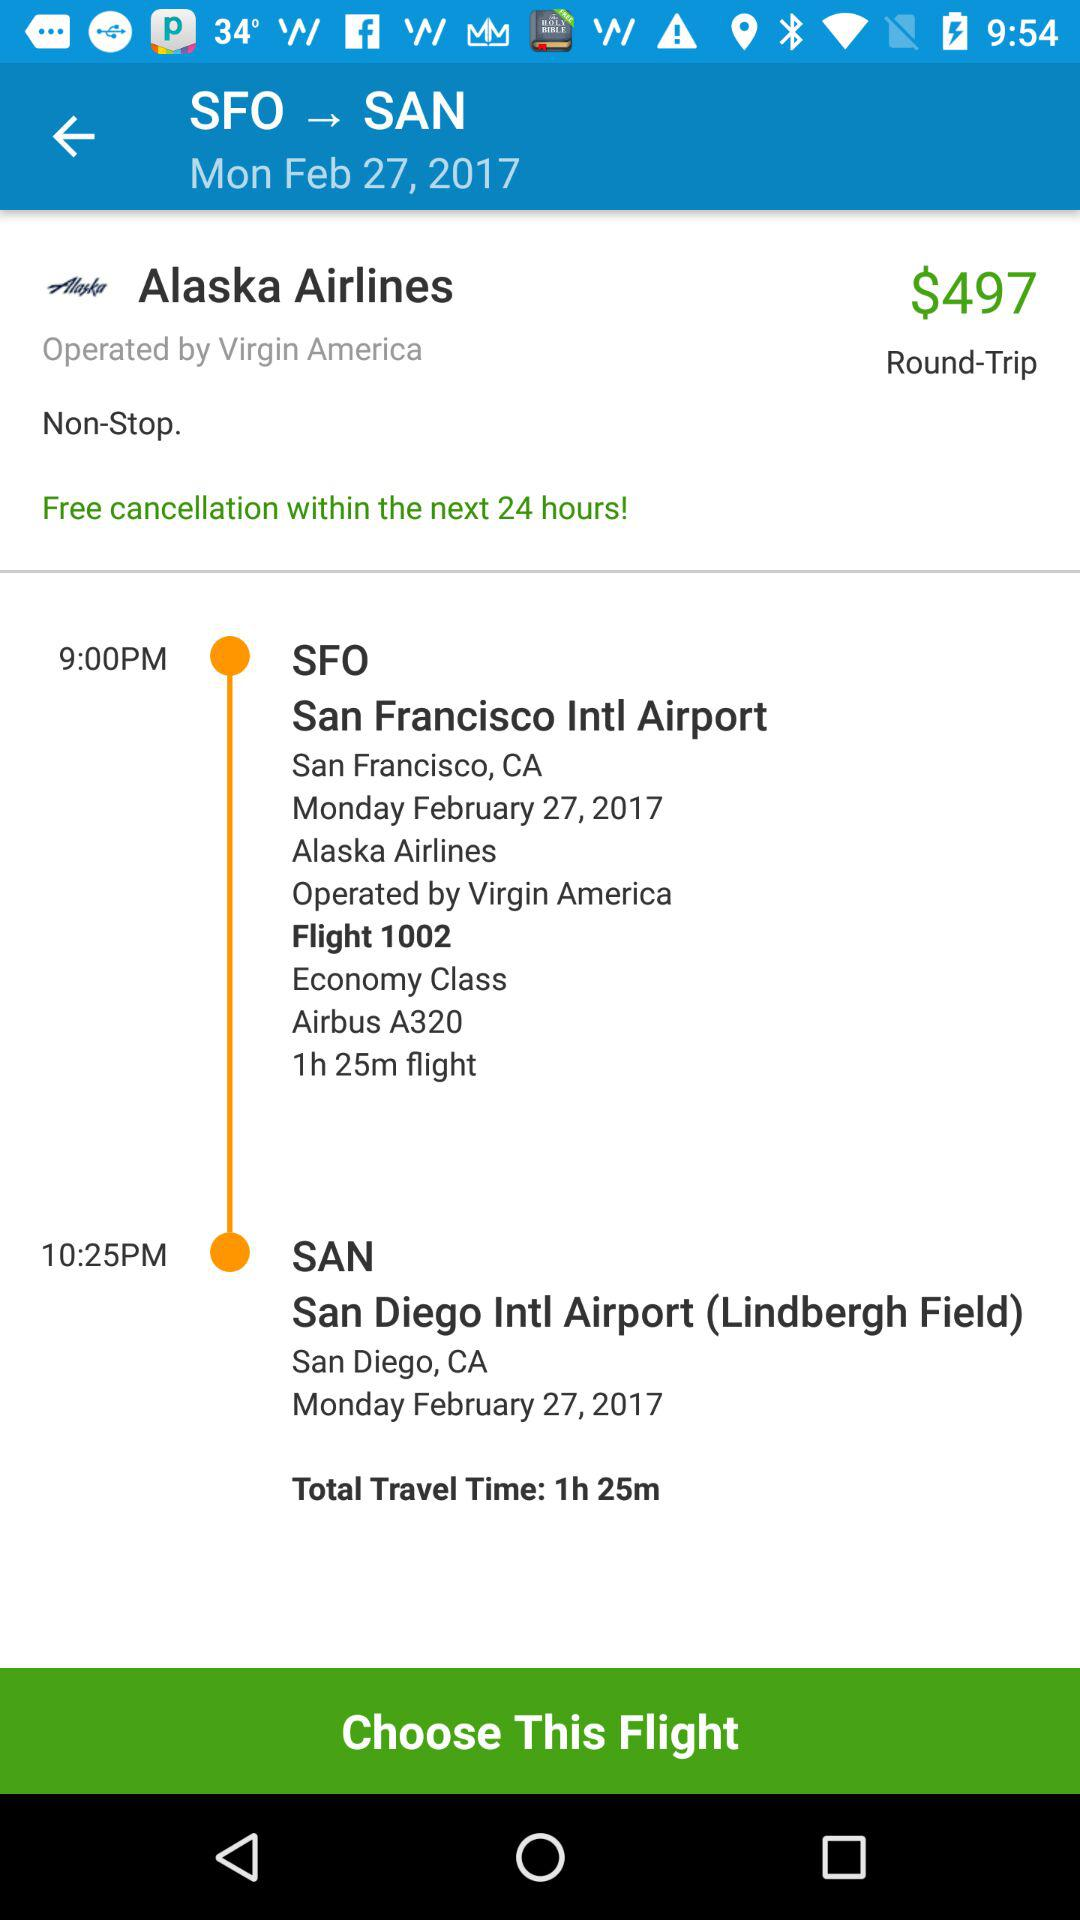How much does the flight cost? The flight costs $497. 